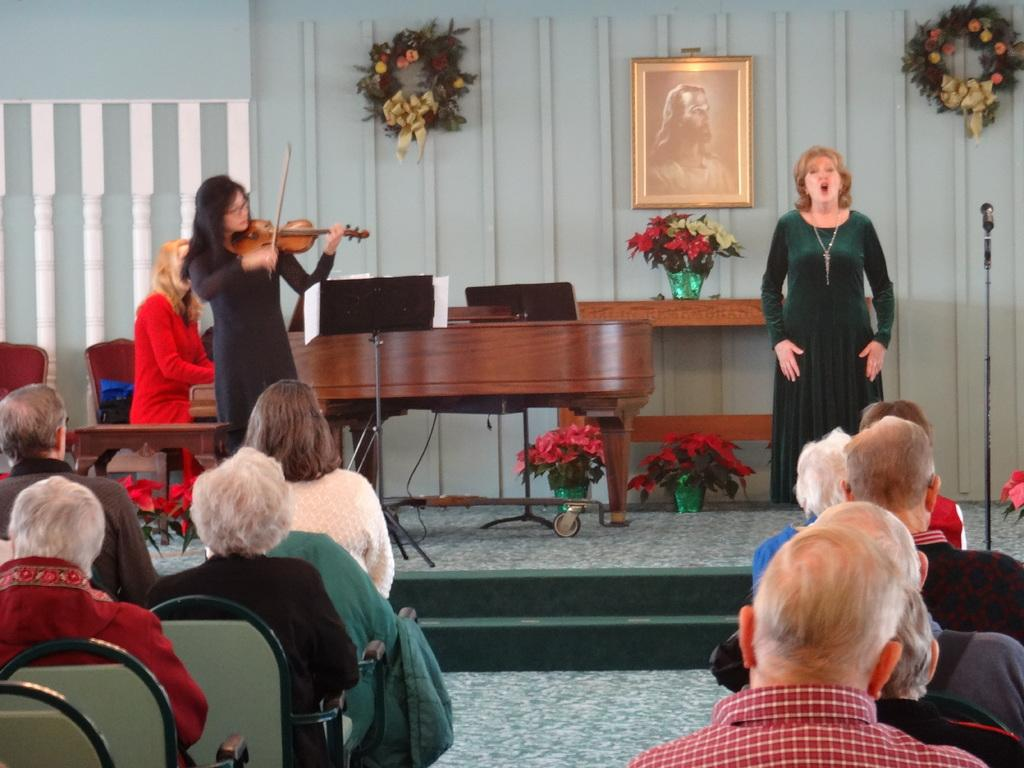How many people are in the image? There is a group of people in the image. What are some of the people in the image doing? Some people are sitting on chairs, while others are standing. What activity is the woman in the image engaged in? The woman is playing a musical instrument. What color is the kettle in the image? There is no kettle present in the image. How many eyes does the woman playing the musical instrument have? The image does not provide enough detail to determine the number of eyes the woman has. 